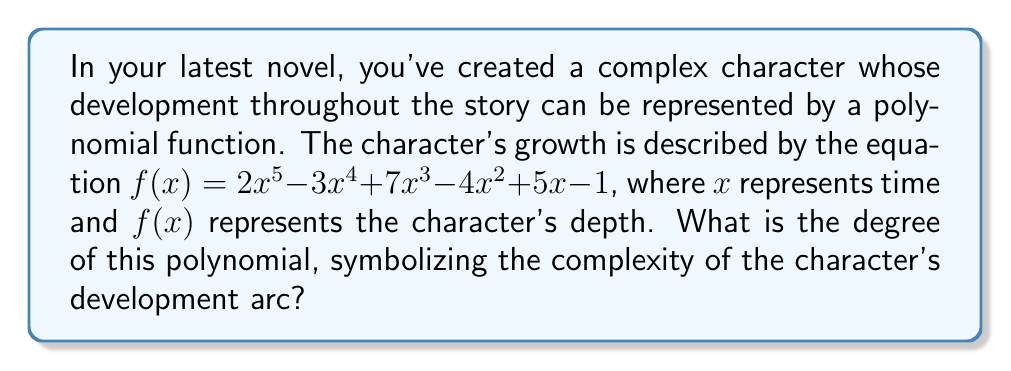Can you solve this math problem? To determine the degree of a polynomial, we need to identify the highest power of the variable in the equation. Let's break down the given polynomial:

1. $2x^5$: The highest power of $x$ is 5
2. $-3x^4$: The power of $x$ is 4
3. $7x^3$: The power of $x$ is 3
4. $-4x^2$: The power of $x$ is 2
5. $5x$: The power of $x$ is 1
6. $-1$: This is a constant term with no $x$

The highest power of $x$ in this polynomial is 5, which appears in the term $2x^5$. Therefore, the degree of this polynomial is 5.

In the context of character development, a higher degree polynomial suggests a more complex character arc, with potentially more nuanced changes and growth throughout the story. A 5th-degree polynomial indicates a character with a rich, multifaceted development, potentially experiencing multiple turning points or phases of growth.
Answer: 5 